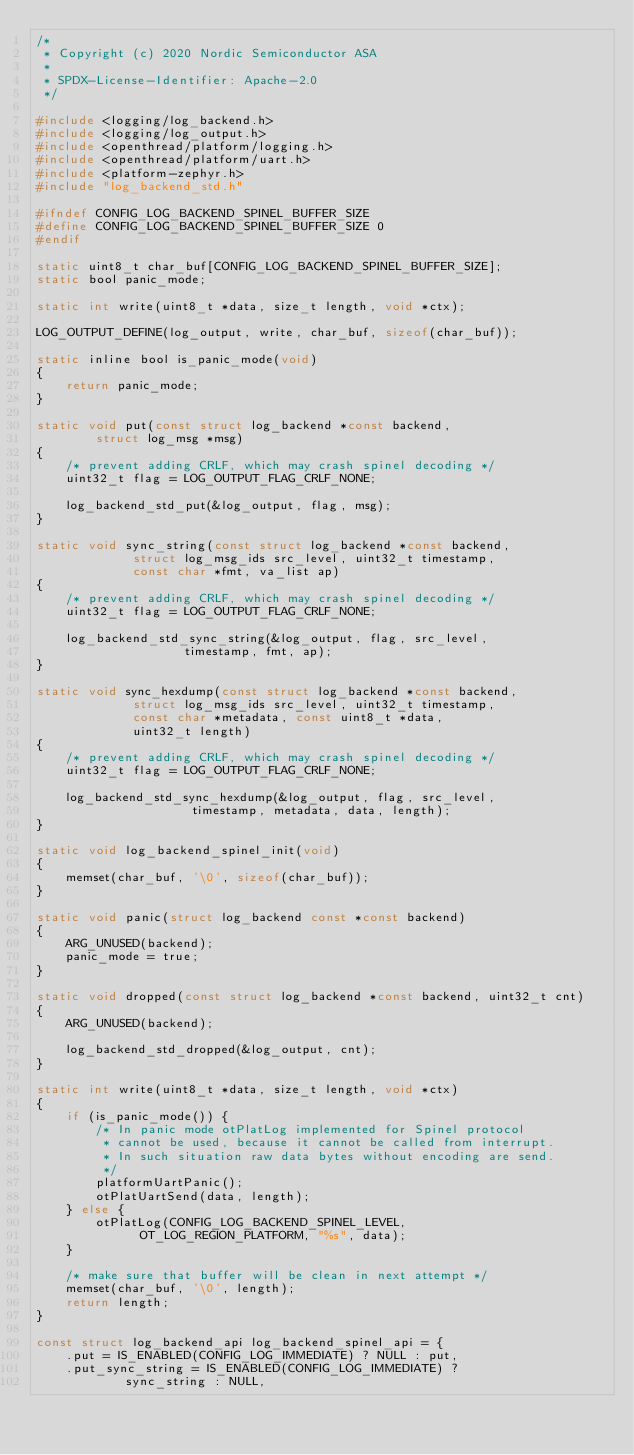Convert code to text. <code><loc_0><loc_0><loc_500><loc_500><_C_>/*
 * Copyright (c) 2020 Nordic Semiconductor ASA
 *
 * SPDX-License-Identifier: Apache-2.0
 */

#include <logging/log_backend.h>
#include <logging/log_output.h>
#include <openthread/platform/logging.h>
#include <openthread/platform/uart.h>
#include <platform-zephyr.h>
#include "log_backend_std.h"

#ifndef CONFIG_LOG_BACKEND_SPINEL_BUFFER_SIZE
#define CONFIG_LOG_BACKEND_SPINEL_BUFFER_SIZE 0
#endif

static uint8_t char_buf[CONFIG_LOG_BACKEND_SPINEL_BUFFER_SIZE];
static bool panic_mode;

static int write(uint8_t *data, size_t length, void *ctx);

LOG_OUTPUT_DEFINE(log_output, write, char_buf, sizeof(char_buf));

static inline bool is_panic_mode(void)
{
	return panic_mode;
}

static void put(const struct log_backend *const backend,
		struct log_msg *msg)
{
	/* prevent adding CRLF, which may crash spinel decoding */
	uint32_t flag = LOG_OUTPUT_FLAG_CRLF_NONE;

	log_backend_std_put(&log_output, flag, msg);
}

static void sync_string(const struct log_backend *const backend,
			 struct log_msg_ids src_level, uint32_t timestamp,
			 const char *fmt, va_list ap)
{
	/* prevent adding CRLF, which may crash spinel decoding */
	uint32_t flag = LOG_OUTPUT_FLAG_CRLF_NONE;

	log_backend_std_sync_string(&log_output, flag, src_level,
				    timestamp, fmt, ap);
}

static void sync_hexdump(const struct log_backend *const backend,
			 struct log_msg_ids src_level, uint32_t timestamp,
			 const char *metadata, const uint8_t *data,
			 uint32_t length)
{
	/* prevent adding CRLF, which may crash spinel decoding */
	uint32_t flag = LOG_OUTPUT_FLAG_CRLF_NONE;

	log_backend_std_sync_hexdump(&log_output, flag, src_level,
				     timestamp, metadata, data, length);
}

static void log_backend_spinel_init(void)
{
	memset(char_buf, '\0', sizeof(char_buf));
}

static void panic(struct log_backend const *const backend)
{
	ARG_UNUSED(backend);
	panic_mode = true;
}

static void dropped(const struct log_backend *const backend, uint32_t cnt)
{
	ARG_UNUSED(backend);

	log_backend_std_dropped(&log_output, cnt);
}

static int write(uint8_t *data, size_t length, void *ctx)
{
	if (is_panic_mode()) {
		/* In panic mode otPlatLog implemented for Spinel protocol
		 * cannot be used, because it cannot be called from interrupt.
		 * In such situation raw data bytes without encoding are send.
		 */
		platformUartPanic();
		otPlatUartSend(data, length);
	} else {
		otPlatLog(CONFIG_LOG_BACKEND_SPINEL_LEVEL,
			  OT_LOG_REGION_PLATFORM, "%s", data);
	}

	/* make sure that buffer will be clean in next attempt */
	memset(char_buf, '\0', length);
	return length;
}

const struct log_backend_api log_backend_spinel_api = {
	.put = IS_ENABLED(CONFIG_LOG_IMMEDIATE) ? NULL : put,
	.put_sync_string = IS_ENABLED(CONFIG_LOG_IMMEDIATE) ?
			sync_string : NULL,</code> 